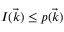Convert formula to latex. <formula><loc_0><loc_0><loc_500><loc_500>I ( \vec { k } ) \leq p ( \vec { k } )</formula> 